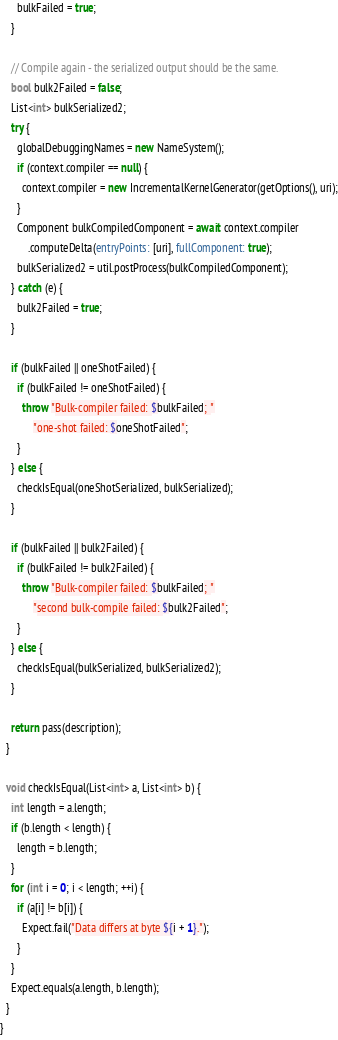<code> <loc_0><loc_0><loc_500><loc_500><_Dart_>      bulkFailed = true;
    }

    // Compile again - the serialized output should be the same.
    bool bulk2Failed = false;
    List<int> bulkSerialized2;
    try {
      globalDebuggingNames = new NameSystem();
      if (context.compiler == null) {
        context.compiler = new IncrementalKernelGenerator(getOptions(), uri);
      }
      Component bulkCompiledComponent = await context.compiler
          .computeDelta(entryPoints: [uri], fullComponent: true);
      bulkSerialized2 = util.postProcess(bulkCompiledComponent);
    } catch (e) {
      bulk2Failed = true;
    }

    if (bulkFailed || oneShotFailed) {
      if (bulkFailed != oneShotFailed) {
        throw "Bulk-compiler failed: $bulkFailed; "
            "one-shot failed: $oneShotFailed";
      }
    } else {
      checkIsEqual(oneShotSerialized, bulkSerialized);
    }

    if (bulkFailed || bulk2Failed) {
      if (bulkFailed != bulk2Failed) {
        throw "Bulk-compiler failed: $bulkFailed; "
            "second bulk-compile failed: $bulk2Failed";
      }
    } else {
      checkIsEqual(bulkSerialized, bulkSerialized2);
    }

    return pass(description);
  }

  void checkIsEqual(List<int> a, List<int> b) {
    int length = a.length;
    if (b.length < length) {
      length = b.length;
    }
    for (int i = 0; i < length; ++i) {
      if (a[i] != b[i]) {
        Expect.fail("Data differs at byte ${i + 1}.");
      }
    }
    Expect.equals(a.length, b.length);
  }
}
</code> 